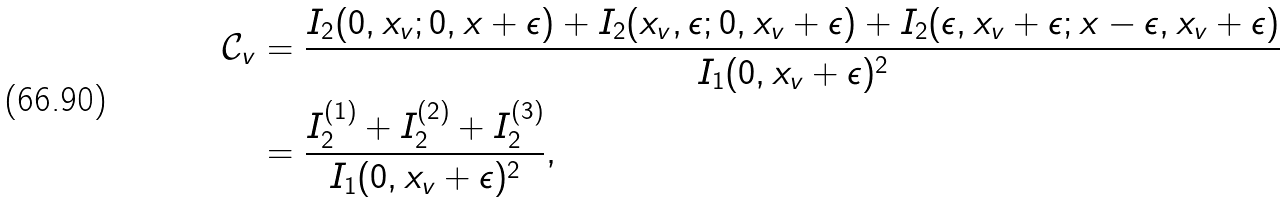<formula> <loc_0><loc_0><loc_500><loc_500>\mathcal { C } _ { v } & = \frac { I _ { 2 } ( 0 , x _ { v } ; 0 , x + \epsilon ) + I _ { 2 } ( x _ { v } , \epsilon ; 0 , x _ { v } + \epsilon ) + I _ { 2 } ( \epsilon , x _ { v } + \epsilon ; x - \epsilon , x _ { v } + \epsilon ) } { I _ { 1 } ( 0 , x _ { v } + \epsilon ) ^ { 2 } } \\ & = \frac { I _ { 2 } ^ { ( 1 ) } + I _ { 2 } ^ { ( 2 ) } + I _ { 2 } ^ { ( 3 ) } } { I _ { 1 } ( 0 , x _ { v } + \epsilon ) ^ { 2 } } ,</formula> 